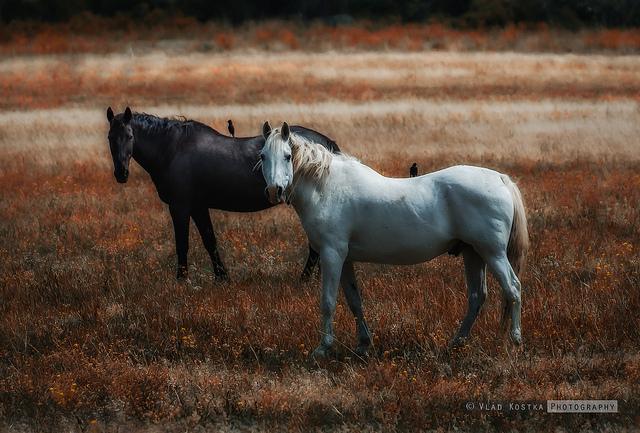How many horses in the field?
Give a very brief answer. 2. How many horses can be seen?
Give a very brief answer. 2. How many man sitiing on the elephant?
Give a very brief answer. 0. 